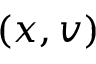Convert formula to latex. <formula><loc_0><loc_0><loc_500><loc_500>( x , v )</formula> 